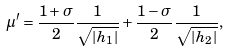<formula> <loc_0><loc_0><loc_500><loc_500>\mu ^ { \prime } = \frac { 1 + \sigma } { 2 } \frac { 1 } { \sqrt { | h _ { 1 } | } } + \frac { 1 - \sigma } { 2 } \frac { 1 } { \sqrt { | h _ { 2 } | } } ,</formula> 